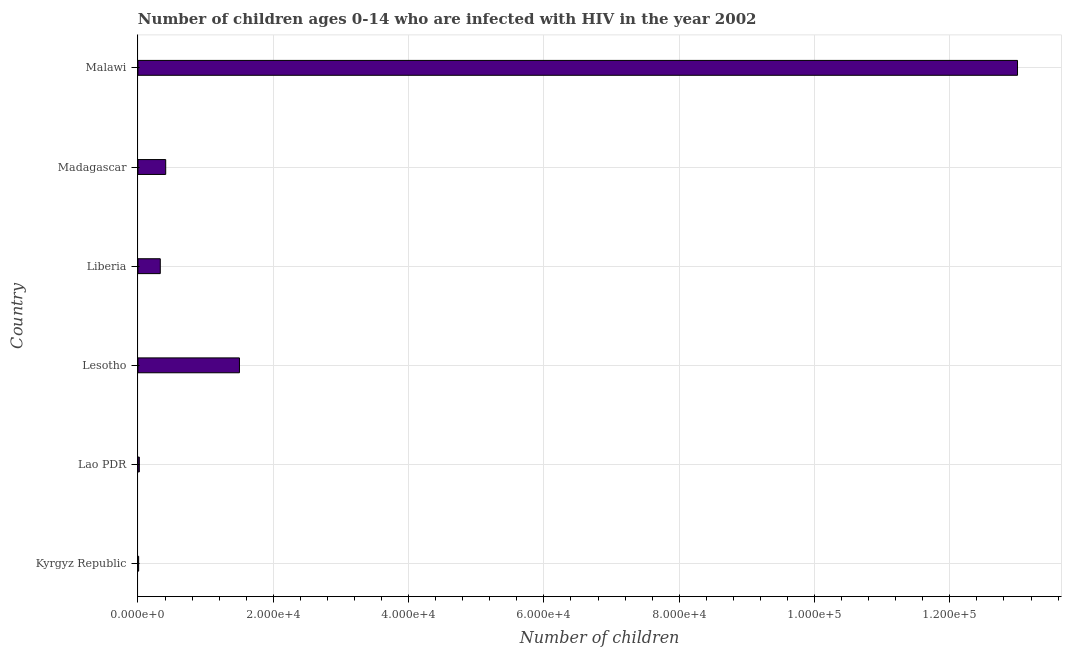Does the graph contain any zero values?
Your answer should be very brief. No. What is the title of the graph?
Offer a very short reply. Number of children ages 0-14 who are infected with HIV in the year 2002. What is the label or title of the X-axis?
Make the answer very short. Number of children. What is the label or title of the Y-axis?
Offer a terse response. Country. What is the number of children living with hiv in Lao PDR?
Give a very brief answer. 200. Across all countries, what is the maximum number of children living with hiv?
Offer a terse response. 1.30e+05. In which country was the number of children living with hiv maximum?
Give a very brief answer. Malawi. In which country was the number of children living with hiv minimum?
Provide a succinct answer. Kyrgyz Republic. What is the sum of the number of children living with hiv?
Your response must be concise. 1.53e+05. What is the difference between the number of children living with hiv in Lesotho and Malawi?
Your answer should be very brief. -1.15e+05. What is the average number of children living with hiv per country?
Make the answer very short. 2.54e+04. What is the median number of children living with hiv?
Keep it short and to the point. 3700. In how many countries, is the number of children living with hiv greater than 92000 ?
Offer a very short reply. 1. What is the ratio of the number of children living with hiv in Lesotho to that in Madagascar?
Make the answer very short. 3.66. Is the number of children living with hiv in Lesotho less than that in Malawi?
Provide a succinct answer. Yes. Is the difference between the number of children living with hiv in Kyrgyz Republic and Lesotho greater than the difference between any two countries?
Offer a terse response. No. What is the difference between the highest and the second highest number of children living with hiv?
Provide a short and direct response. 1.15e+05. Is the sum of the number of children living with hiv in Lao PDR and Malawi greater than the maximum number of children living with hiv across all countries?
Offer a terse response. Yes. What is the difference between the highest and the lowest number of children living with hiv?
Make the answer very short. 1.30e+05. How many bars are there?
Offer a very short reply. 6. What is the difference between two consecutive major ticks on the X-axis?
Offer a very short reply. 2.00e+04. Are the values on the major ticks of X-axis written in scientific E-notation?
Provide a succinct answer. Yes. What is the Number of children of Kyrgyz Republic?
Your response must be concise. 100. What is the Number of children of Lesotho?
Keep it short and to the point. 1.50e+04. What is the Number of children of Liberia?
Provide a short and direct response. 3300. What is the Number of children in Madagascar?
Ensure brevity in your answer.  4100. What is the difference between the Number of children in Kyrgyz Republic and Lao PDR?
Offer a very short reply. -100. What is the difference between the Number of children in Kyrgyz Republic and Lesotho?
Keep it short and to the point. -1.49e+04. What is the difference between the Number of children in Kyrgyz Republic and Liberia?
Provide a short and direct response. -3200. What is the difference between the Number of children in Kyrgyz Republic and Madagascar?
Your answer should be compact. -4000. What is the difference between the Number of children in Kyrgyz Republic and Malawi?
Make the answer very short. -1.30e+05. What is the difference between the Number of children in Lao PDR and Lesotho?
Your response must be concise. -1.48e+04. What is the difference between the Number of children in Lao PDR and Liberia?
Offer a very short reply. -3100. What is the difference between the Number of children in Lao PDR and Madagascar?
Ensure brevity in your answer.  -3900. What is the difference between the Number of children in Lao PDR and Malawi?
Your response must be concise. -1.30e+05. What is the difference between the Number of children in Lesotho and Liberia?
Your answer should be very brief. 1.17e+04. What is the difference between the Number of children in Lesotho and Madagascar?
Offer a very short reply. 1.09e+04. What is the difference between the Number of children in Lesotho and Malawi?
Give a very brief answer. -1.15e+05. What is the difference between the Number of children in Liberia and Madagascar?
Provide a short and direct response. -800. What is the difference between the Number of children in Liberia and Malawi?
Your response must be concise. -1.27e+05. What is the difference between the Number of children in Madagascar and Malawi?
Your answer should be compact. -1.26e+05. What is the ratio of the Number of children in Kyrgyz Republic to that in Lao PDR?
Your answer should be very brief. 0.5. What is the ratio of the Number of children in Kyrgyz Republic to that in Lesotho?
Provide a short and direct response. 0.01. What is the ratio of the Number of children in Kyrgyz Republic to that in Liberia?
Give a very brief answer. 0.03. What is the ratio of the Number of children in Kyrgyz Republic to that in Madagascar?
Make the answer very short. 0.02. What is the ratio of the Number of children in Kyrgyz Republic to that in Malawi?
Keep it short and to the point. 0. What is the ratio of the Number of children in Lao PDR to that in Lesotho?
Your answer should be compact. 0.01. What is the ratio of the Number of children in Lao PDR to that in Liberia?
Your response must be concise. 0.06. What is the ratio of the Number of children in Lao PDR to that in Madagascar?
Keep it short and to the point. 0.05. What is the ratio of the Number of children in Lao PDR to that in Malawi?
Your answer should be compact. 0. What is the ratio of the Number of children in Lesotho to that in Liberia?
Give a very brief answer. 4.54. What is the ratio of the Number of children in Lesotho to that in Madagascar?
Offer a terse response. 3.66. What is the ratio of the Number of children in Lesotho to that in Malawi?
Give a very brief answer. 0.12. What is the ratio of the Number of children in Liberia to that in Madagascar?
Ensure brevity in your answer.  0.81. What is the ratio of the Number of children in Liberia to that in Malawi?
Make the answer very short. 0.03. What is the ratio of the Number of children in Madagascar to that in Malawi?
Offer a terse response. 0.03. 